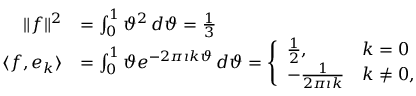Convert formula to latex. <formula><loc_0><loc_0><loc_500><loc_500>{ \begin{array} { r l } { \| f \| ^ { 2 } } & { = \int _ { 0 } ^ { 1 } \vartheta ^ { 2 } \, d \vartheta = { \frac { 1 } { 3 } } } \\ { \langle f , e _ { k } \rangle } & { = \int _ { 0 } ^ { 1 } \vartheta e ^ { - 2 \pi \imath k \vartheta } \, d \vartheta = { \Big \{ \begin{array} { l l } { { \frac { 1 } { 2 } } , } & { k = 0 } \\ { - { \frac { 1 } { 2 \pi \imath k } } } & { k \neq 0 , } \end{array} } } \end{array} }</formula> 